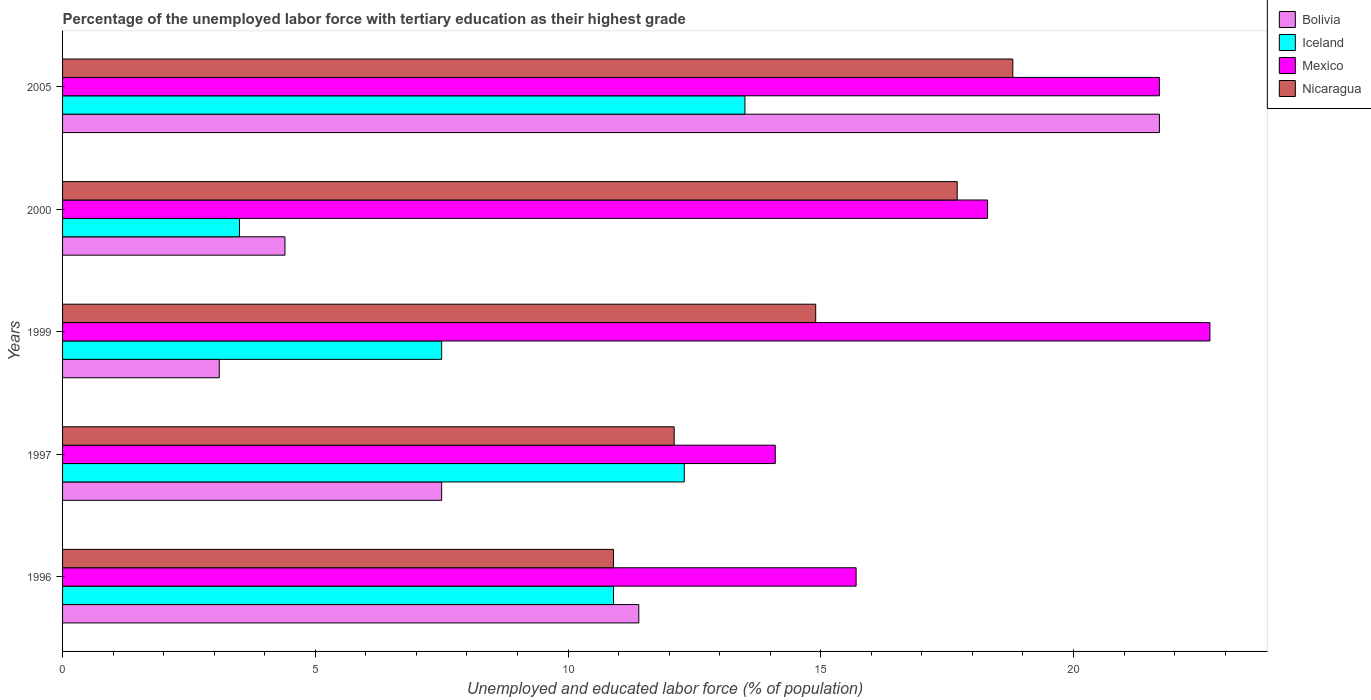How many different coloured bars are there?
Your answer should be compact. 4. How many groups of bars are there?
Provide a succinct answer. 5. Are the number of bars per tick equal to the number of legend labels?
Provide a short and direct response. Yes. What is the label of the 2nd group of bars from the top?
Offer a very short reply. 2000. What is the percentage of the unemployed labor force with tertiary education in Mexico in 1996?
Make the answer very short. 15.7. Across all years, what is the maximum percentage of the unemployed labor force with tertiary education in Nicaragua?
Make the answer very short. 18.8. Across all years, what is the minimum percentage of the unemployed labor force with tertiary education in Nicaragua?
Your answer should be compact. 10.9. What is the total percentage of the unemployed labor force with tertiary education in Nicaragua in the graph?
Your answer should be very brief. 74.4. What is the difference between the percentage of the unemployed labor force with tertiary education in Mexico in 1996 and that in 2005?
Provide a succinct answer. -6. What is the difference between the percentage of the unemployed labor force with tertiary education in Iceland in 2000 and the percentage of the unemployed labor force with tertiary education in Nicaragua in 1999?
Make the answer very short. -11.4. What is the average percentage of the unemployed labor force with tertiary education in Nicaragua per year?
Keep it short and to the point. 14.88. In the year 2000, what is the difference between the percentage of the unemployed labor force with tertiary education in Bolivia and percentage of the unemployed labor force with tertiary education in Nicaragua?
Provide a short and direct response. -13.3. What is the ratio of the percentage of the unemployed labor force with tertiary education in Bolivia in 1997 to that in 1999?
Make the answer very short. 2.42. What is the difference between the highest and the second highest percentage of the unemployed labor force with tertiary education in Iceland?
Make the answer very short. 1.2. What is the difference between the highest and the lowest percentage of the unemployed labor force with tertiary education in Nicaragua?
Give a very brief answer. 7.9. Is the sum of the percentage of the unemployed labor force with tertiary education in Mexico in 1999 and 2000 greater than the maximum percentage of the unemployed labor force with tertiary education in Bolivia across all years?
Make the answer very short. Yes. Is it the case that in every year, the sum of the percentage of the unemployed labor force with tertiary education in Iceland and percentage of the unemployed labor force with tertiary education in Nicaragua is greater than the sum of percentage of the unemployed labor force with tertiary education in Mexico and percentage of the unemployed labor force with tertiary education in Bolivia?
Your answer should be compact. No. What does the 1st bar from the top in 2005 represents?
Offer a very short reply. Nicaragua. What does the 3rd bar from the bottom in 2000 represents?
Your answer should be compact. Mexico. Is it the case that in every year, the sum of the percentage of the unemployed labor force with tertiary education in Nicaragua and percentage of the unemployed labor force with tertiary education in Mexico is greater than the percentage of the unemployed labor force with tertiary education in Iceland?
Provide a succinct answer. Yes. How many bars are there?
Your answer should be compact. 20. Does the graph contain any zero values?
Your response must be concise. No. Does the graph contain grids?
Your answer should be compact. No. Where does the legend appear in the graph?
Offer a terse response. Top right. How many legend labels are there?
Your response must be concise. 4. How are the legend labels stacked?
Provide a succinct answer. Vertical. What is the title of the graph?
Provide a short and direct response. Percentage of the unemployed labor force with tertiary education as their highest grade. What is the label or title of the X-axis?
Your answer should be compact. Unemployed and educated labor force (% of population). What is the Unemployed and educated labor force (% of population) of Bolivia in 1996?
Provide a succinct answer. 11.4. What is the Unemployed and educated labor force (% of population) of Iceland in 1996?
Offer a terse response. 10.9. What is the Unemployed and educated labor force (% of population) in Mexico in 1996?
Give a very brief answer. 15.7. What is the Unemployed and educated labor force (% of population) in Nicaragua in 1996?
Your response must be concise. 10.9. What is the Unemployed and educated labor force (% of population) in Bolivia in 1997?
Provide a succinct answer. 7.5. What is the Unemployed and educated labor force (% of population) of Iceland in 1997?
Offer a very short reply. 12.3. What is the Unemployed and educated labor force (% of population) in Mexico in 1997?
Keep it short and to the point. 14.1. What is the Unemployed and educated labor force (% of population) in Nicaragua in 1997?
Offer a terse response. 12.1. What is the Unemployed and educated labor force (% of population) of Bolivia in 1999?
Offer a terse response. 3.1. What is the Unemployed and educated labor force (% of population) in Mexico in 1999?
Keep it short and to the point. 22.7. What is the Unemployed and educated labor force (% of population) in Nicaragua in 1999?
Give a very brief answer. 14.9. What is the Unemployed and educated labor force (% of population) in Bolivia in 2000?
Your answer should be compact. 4.4. What is the Unemployed and educated labor force (% of population) of Mexico in 2000?
Provide a short and direct response. 18.3. What is the Unemployed and educated labor force (% of population) in Nicaragua in 2000?
Give a very brief answer. 17.7. What is the Unemployed and educated labor force (% of population) of Bolivia in 2005?
Your response must be concise. 21.7. What is the Unemployed and educated labor force (% of population) in Mexico in 2005?
Your answer should be very brief. 21.7. What is the Unemployed and educated labor force (% of population) of Nicaragua in 2005?
Provide a succinct answer. 18.8. Across all years, what is the maximum Unemployed and educated labor force (% of population) of Bolivia?
Your answer should be compact. 21.7. Across all years, what is the maximum Unemployed and educated labor force (% of population) in Iceland?
Your response must be concise. 13.5. Across all years, what is the maximum Unemployed and educated labor force (% of population) in Mexico?
Your answer should be compact. 22.7. Across all years, what is the maximum Unemployed and educated labor force (% of population) in Nicaragua?
Ensure brevity in your answer.  18.8. Across all years, what is the minimum Unemployed and educated labor force (% of population) in Bolivia?
Keep it short and to the point. 3.1. Across all years, what is the minimum Unemployed and educated labor force (% of population) in Iceland?
Offer a very short reply. 3.5. Across all years, what is the minimum Unemployed and educated labor force (% of population) in Mexico?
Provide a short and direct response. 14.1. Across all years, what is the minimum Unemployed and educated labor force (% of population) of Nicaragua?
Your answer should be compact. 10.9. What is the total Unemployed and educated labor force (% of population) of Bolivia in the graph?
Keep it short and to the point. 48.1. What is the total Unemployed and educated labor force (% of population) in Iceland in the graph?
Provide a succinct answer. 47.7. What is the total Unemployed and educated labor force (% of population) of Mexico in the graph?
Offer a very short reply. 92.5. What is the total Unemployed and educated labor force (% of population) in Nicaragua in the graph?
Provide a succinct answer. 74.4. What is the difference between the Unemployed and educated labor force (% of population) in Bolivia in 1996 and that in 1997?
Keep it short and to the point. 3.9. What is the difference between the Unemployed and educated labor force (% of population) of Mexico in 1996 and that in 1997?
Provide a succinct answer. 1.6. What is the difference between the Unemployed and educated labor force (% of population) in Nicaragua in 1996 and that in 1997?
Provide a short and direct response. -1.2. What is the difference between the Unemployed and educated labor force (% of population) in Bolivia in 1996 and that in 1999?
Your answer should be very brief. 8.3. What is the difference between the Unemployed and educated labor force (% of population) of Mexico in 1996 and that in 1999?
Ensure brevity in your answer.  -7. What is the difference between the Unemployed and educated labor force (% of population) in Iceland in 1996 and that in 2000?
Your answer should be compact. 7.4. What is the difference between the Unemployed and educated labor force (% of population) in Nicaragua in 1996 and that in 2000?
Provide a succinct answer. -6.8. What is the difference between the Unemployed and educated labor force (% of population) in Mexico in 1996 and that in 2005?
Your answer should be compact. -6. What is the difference between the Unemployed and educated labor force (% of population) of Bolivia in 1997 and that in 1999?
Make the answer very short. 4.4. What is the difference between the Unemployed and educated labor force (% of population) in Mexico in 1997 and that in 1999?
Give a very brief answer. -8.6. What is the difference between the Unemployed and educated labor force (% of population) of Nicaragua in 1997 and that in 1999?
Your response must be concise. -2.8. What is the difference between the Unemployed and educated labor force (% of population) in Iceland in 1997 and that in 2000?
Make the answer very short. 8.8. What is the difference between the Unemployed and educated labor force (% of population) in Bolivia in 1997 and that in 2005?
Keep it short and to the point. -14.2. What is the difference between the Unemployed and educated labor force (% of population) of Mexico in 1997 and that in 2005?
Offer a terse response. -7.6. What is the difference between the Unemployed and educated labor force (% of population) of Mexico in 1999 and that in 2000?
Give a very brief answer. 4.4. What is the difference between the Unemployed and educated labor force (% of population) of Bolivia in 1999 and that in 2005?
Provide a short and direct response. -18.6. What is the difference between the Unemployed and educated labor force (% of population) in Iceland in 1999 and that in 2005?
Provide a succinct answer. -6. What is the difference between the Unemployed and educated labor force (% of population) in Bolivia in 2000 and that in 2005?
Provide a short and direct response. -17.3. What is the difference between the Unemployed and educated labor force (% of population) of Nicaragua in 2000 and that in 2005?
Your answer should be compact. -1.1. What is the difference between the Unemployed and educated labor force (% of population) of Bolivia in 1996 and the Unemployed and educated labor force (% of population) of Iceland in 1999?
Offer a terse response. 3.9. What is the difference between the Unemployed and educated labor force (% of population) of Bolivia in 1996 and the Unemployed and educated labor force (% of population) of Mexico in 1999?
Keep it short and to the point. -11.3. What is the difference between the Unemployed and educated labor force (% of population) in Bolivia in 1996 and the Unemployed and educated labor force (% of population) in Mexico in 2000?
Ensure brevity in your answer.  -6.9. What is the difference between the Unemployed and educated labor force (% of population) of Bolivia in 1996 and the Unemployed and educated labor force (% of population) of Nicaragua in 2000?
Your answer should be very brief. -6.3. What is the difference between the Unemployed and educated labor force (% of population) in Iceland in 1996 and the Unemployed and educated labor force (% of population) in Nicaragua in 2000?
Keep it short and to the point. -6.8. What is the difference between the Unemployed and educated labor force (% of population) in Mexico in 1996 and the Unemployed and educated labor force (% of population) in Nicaragua in 2000?
Your answer should be compact. -2. What is the difference between the Unemployed and educated labor force (% of population) in Bolivia in 1996 and the Unemployed and educated labor force (% of population) in Iceland in 2005?
Provide a succinct answer. -2.1. What is the difference between the Unemployed and educated labor force (% of population) in Iceland in 1996 and the Unemployed and educated labor force (% of population) in Mexico in 2005?
Ensure brevity in your answer.  -10.8. What is the difference between the Unemployed and educated labor force (% of population) of Bolivia in 1997 and the Unemployed and educated labor force (% of population) of Iceland in 1999?
Give a very brief answer. 0. What is the difference between the Unemployed and educated labor force (% of population) of Bolivia in 1997 and the Unemployed and educated labor force (% of population) of Mexico in 1999?
Offer a very short reply. -15.2. What is the difference between the Unemployed and educated labor force (% of population) of Mexico in 1997 and the Unemployed and educated labor force (% of population) of Nicaragua in 1999?
Give a very brief answer. -0.8. What is the difference between the Unemployed and educated labor force (% of population) of Bolivia in 1997 and the Unemployed and educated labor force (% of population) of Nicaragua in 2000?
Your answer should be compact. -10.2. What is the difference between the Unemployed and educated labor force (% of population) of Iceland in 1997 and the Unemployed and educated labor force (% of population) of Mexico in 2000?
Offer a terse response. -6. What is the difference between the Unemployed and educated labor force (% of population) in Iceland in 1997 and the Unemployed and educated labor force (% of population) in Nicaragua in 2000?
Ensure brevity in your answer.  -5.4. What is the difference between the Unemployed and educated labor force (% of population) of Mexico in 1997 and the Unemployed and educated labor force (% of population) of Nicaragua in 2000?
Make the answer very short. -3.6. What is the difference between the Unemployed and educated labor force (% of population) of Bolivia in 1997 and the Unemployed and educated labor force (% of population) of Nicaragua in 2005?
Your answer should be compact. -11.3. What is the difference between the Unemployed and educated labor force (% of population) in Bolivia in 1999 and the Unemployed and educated labor force (% of population) in Mexico in 2000?
Keep it short and to the point. -15.2. What is the difference between the Unemployed and educated labor force (% of population) of Bolivia in 1999 and the Unemployed and educated labor force (% of population) of Nicaragua in 2000?
Your answer should be very brief. -14.6. What is the difference between the Unemployed and educated labor force (% of population) in Mexico in 1999 and the Unemployed and educated labor force (% of population) in Nicaragua in 2000?
Your answer should be compact. 5. What is the difference between the Unemployed and educated labor force (% of population) of Bolivia in 1999 and the Unemployed and educated labor force (% of population) of Iceland in 2005?
Ensure brevity in your answer.  -10.4. What is the difference between the Unemployed and educated labor force (% of population) in Bolivia in 1999 and the Unemployed and educated labor force (% of population) in Mexico in 2005?
Your answer should be compact. -18.6. What is the difference between the Unemployed and educated labor force (% of population) in Bolivia in 1999 and the Unemployed and educated labor force (% of population) in Nicaragua in 2005?
Make the answer very short. -15.7. What is the difference between the Unemployed and educated labor force (% of population) of Iceland in 1999 and the Unemployed and educated labor force (% of population) of Nicaragua in 2005?
Provide a succinct answer. -11.3. What is the difference between the Unemployed and educated labor force (% of population) in Bolivia in 2000 and the Unemployed and educated labor force (% of population) in Mexico in 2005?
Give a very brief answer. -17.3. What is the difference between the Unemployed and educated labor force (% of population) in Bolivia in 2000 and the Unemployed and educated labor force (% of population) in Nicaragua in 2005?
Your answer should be compact. -14.4. What is the difference between the Unemployed and educated labor force (% of population) in Iceland in 2000 and the Unemployed and educated labor force (% of population) in Mexico in 2005?
Make the answer very short. -18.2. What is the difference between the Unemployed and educated labor force (% of population) of Iceland in 2000 and the Unemployed and educated labor force (% of population) of Nicaragua in 2005?
Keep it short and to the point. -15.3. What is the average Unemployed and educated labor force (% of population) of Bolivia per year?
Provide a succinct answer. 9.62. What is the average Unemployed and educated labor force (% of population) in Iceland per year?
Offer a very short reply. 9.54. What is the average Unemployed and educated labor force (% of population) of Mexico per year?
Ensure brevity in your answer.  18.5. What is the average Unemployed and educated labor force (% of population) of Nicaragua per year?
Your answer should be very brief. 14.88. In the year 1996, what is the difference between the Unemployed and educated labor force (% of population) in Bolivia and Unemployed and educated labor force (% of population) in Iceland?
Offer a terse response. 0.5. In the year 1996, what is the difference between the Unemployed and educated labor force (% of population) in Bolivia and Unemployed and educated labor force (% of population) in Mexico?
Provide a succinct answer. -4.3. In the year 1996, what is the difference between the Unemployed and educated labor force (% of population) in Iceland and Unemployed and educated labor force (% of population) in Mexico?
Offer a terse response. -4.8. In the year 1996, what is the difference between the Unemployed and educated labor force (% of population) of Mexico and Unemployed and educated labor force (% of population) of Nicaragua?
Ensure brevity in your answer.  4.8. In the year 1997, what is the difference between the Unemployed and educated labor force (% of population) of Bolivia and Unemployed and educated labor force (% of population) of Mexico?
Ensure brevity in your answer.  -6.6. In the year 1997, what is the difference between the Unemployed and educated labor force (% of population) in Iceland and Unemployed and educated labor force (% of population) in Nicaragua?
Your answer should be very brief. 0.2. In the year 1997, what is the difference between the Unemployed and educated labor force (% of population) in Mexico and Unemployed and educated labor force (% of population) in Nicaragua?
Offer a terse response. 2. In the year 1999, what is the difference between the Unemployed and educated labor force (% of population) of Bolivia and Unemployed and educated labor force (% of population) of Iceland?
Your answer should be compact. -4.4. In the year 1999, what is the difference between the Unemployed and educated labor force (% of population) in Bolivia and Unemployed and educated labor force (% of population) in Mexico?
Offer a very short reply. -19.6. In the year 1999, what is the difference between the Unemployed and educated labor force (% of population) of Bolivia and Unemployed and educated labor force (% of population) of Nicaragua?
Provide a succinct answer. -11.8. In the year 1999, what is the difference between the Unemployed and educated labor force (% of population) of Iceland and Unemployed and educated labor force (% of population) of Mexico?
Your answer should be compact. -15.2. In the year 1999, what is the difference between the Unemployed and educated labor force (% of population) of Mexico and Unemployed and educated labor force (% of population) of Nicaragua?
Your answer should be very brief. 7.8. In the year 2000, what is the difference between the Unemployed and educated labor force (% of population) in Bolivia and Unemployed and educated labor force (% of population) in Iceland?
Give a very brief answer. 0.9. In the year 2000, what is the difference between the Unemployed and educated labor force (% of population) in Bolivia and Unemployed and educated labor force (% of population) in Mexico?
Offer a terse response. -13.9. In the year 2000, what is the difference between the Unemployed and educated labor force (% of population) of Bolivia and Unemployed and educated labor force (% of population) of Nicaragua?
Your response must be concise. -13.3. In the year 2000, what is the difference between the Unemployed and educated labor force (% of population) of Iceland and Unemployed and educated labor force (% of population) of Mexico?
Ensure brevity in your answer.  -14.8. In the year 2005, what is the difference between the Unemployed and educated labor force (% of population) in Bolivia and Unemployed and educated labor force (% of population) in Mexico?
Ensure brevity in your answer.  0. In the year 2005, what is the difference between the Unemployed and educated labor force (% of population) in Iceland and Unemployed and educated labor force (% of population) in Mexico?
Offer a terse response. -8.2. In the year 2005, what is the difference between the Unemployed and educated labor force (% of population) in Mexico and Unemployed and educated labor force (% of population) in Nicaragua?
Make the answer very short. 2.9. What is the ratio of the Unemployed and educated labor force (% of population) of Bolivia in 1996 to that in 1997?
Your response must be concise. 1.52. What is the ratio of the Unemployed and educated labor force (% of population) of Iceland in 1996 to that in 1997?
Your response must be concise. 0.89. What is the ratio of the Unemployed and educated labor force (% of population) in Mexico in 1996 to that in 1997?
Make the answer very short. 1.11. What is the ratio of the Unemployed and educated labor force (% of population) in Nicaragua in 1996 to that in 1997?
Your answer should be compact. 0.9. What is the ratio of the Unemployed and educated labor force (% of population) of Bolivia in 1996 to that in 1999?
Your answer should be very brief. 3.68. What is the ratio of the Unemployed and educated labor force (% of population) of Iceland in 1996 to that in 1999?
Give a very brief answer. 1.45. What is the ratio of the Unemployed and educated labor force (% of population) in Mexico in 1996 to that in 1999?
Offer a terse response. 0.69. What is the ratio of the Unemployed and educated labor force (% of population) in Nicaragua in 1996 to that in 1999?
Keep it short and to the point. 0.73. What is the ratio of the Unemployed and educated labor force (% of population) of Bolivia in 1996 to that in 2000?
Keep it short and to the point. 2.59. What is the ratio of the Unemployed and educated labor force (% of population) in Iceland in 1996 to that in 2000?
Ensure brevity in your answer.  3.11. What is the ratio of the Unemployed and educated labor force (% of population) in Mexico in 1996 to that in 2000?
Offer a very short reply. 0.86. What is the ratio of the Unemployed and educated labor force (% of population) of Nicaragua in 1996 to that in 2000?
Give a very brief answer. 0.62. What is the ratio of the Unemployed and educated labor force (% of population) in Bolivia in 1996 to that in 2005?
Ensure brevity in your answer.  0.53. What is the ratio of the Unemployed and educated labor force (% of population) in Iceland in 1996 to that in 2005?
Your response must be concise. 0.81. What is the ratio of the Unemployed and educated labor force (% of population) of Mexico in 1996 to that in 2005?
Ensure brevity in your answer.  0.72. What is the ratio of the Unemployed and educated labor force (% of population) in Nicaragua in 1996 to that in 2005?
Your response must be concise. 0.58. What is the ratio of the Unemployed and educated labor force (% of population) in Bolivia in 1997 to that in 1999?
Your answer should be very brief. 2.42. What is the ratio of the Unemployed and educated labor force (% of population) in Iceland in 1997 to that in 1999?
Your response must be concise. 1.64. What is the ratio of the Unemployed and educated labor force (% of population) in Mexico in 1997 to that in 1999?
Your answer should be compact. 0.62. What is the ratio of the Unemployed and educated labor force (% of population) in Nicaragua in 1997 to that in 1999?
Offer a very short reply. 0.81. What is the ratio of the Unemployed and educated labor force (% of population) in Bolivia in 1997 to that in 2000?
Your response must be concise. 1.7. What is the ratio of the Unemployed and educated labor force (% of population) in Iceland in 1997 to that in 2000?
Make the answer very short. 3.51. What is the ratio of the Unemployed and educated labor force (% of population) in Mexico in 1997 to that in 2000?
Provide a short and direct response. 0.77. What is the ratio of the Unemployed and educated labor force (% of population) of Nicaragua in 1997 to that in 2000?
Provide a short and direct response. 0.68. What is the ratio of the Unemployed and educated labor force (% of population) in Bolivia in 1997 to that in 2005?
Offer a terse response. 0.35. What is the ratio of the Unemployed and educated labor force (% of population) of Iceland in 1997 to that in 2005?
Make the answer very short. 0.91. What is the ratio of the Unemployed and educated labor force (% of population) in Mexico in 1997 to that in 2005?
Offer a very short reply. 0.65. What is the ratio of the Unemployed and educated labor force (% of population) in Nicaragua in 1997 to that in 2005?
Offer a very short reply. 0.64. What is the ratio of the Unemployed and educated labor force (% of population) in Bolivia in 1999 to that in 2000?
Make the answer very short. 0.7. What is the ratio of the Unemployed and educated labor force (% of population) of Iceland in 1999 to that in 2000?
Offer a very short reply. 2.14. What is the ratio of the Unemployed and educated labor force (% of population) in Mexico in 1999 to that in 2000?
Your answer should be compact. 1.24. What is the ratio of the Unemployed and educated labor force (% of population) in Nicaragua in 1999 to that in 2000?
Your response must be concise. 0.84. What is the ratio of the Unemployed and educated labor force (% of population) in Bolivia in 1999 to that in 2005?
Give a very brief answer. 0.14. What is the ratio of the Unemployed and educated labor force (% of population) in Iceland in 1999 to that in 2005?
Ensure brevity in your answer.  0.56. What is the ratio of the Unemployed and educated labor force (% of population) in Mexico in 1999 to that in 2005?
Make the answer very short. 1.05. What is the ratio of the Unemployed and educated labor force (% of population) of Nicaragua in 1999 to that in 2005?
Make the answer very short. 0.79. What is the ratio of the Unemployed and educated labor force (% of population) of Bolivia in 2000 to that in 2005?
Ensure brevity in your answer.  0.2. What is the ratio of the Unemployed and educated labor force (% of population) of Iceland in 2000 to that in 2005?
Provide a succinct answer. 0.26. What is the ratio of the Unemployed and educated labor force (% of population) in Mexico in 2000 to that in 2005?
Make the answer very short. 0.84. What is the ratio of the Unemployed and educated labor force (% of population) in Nicaragua in 2000 to that in 2005?
Your response must be concise. 0.94. What is the difference between the highest and the second highest Unemployed and educated labor force (% of population) of Mexico?
Your answer should be very brief. 1. What is the difference between the highest and the lowest Unemployed and educated labor force (% of population) in Bolivia?
Ensure brevity in your answer.  18.6. 